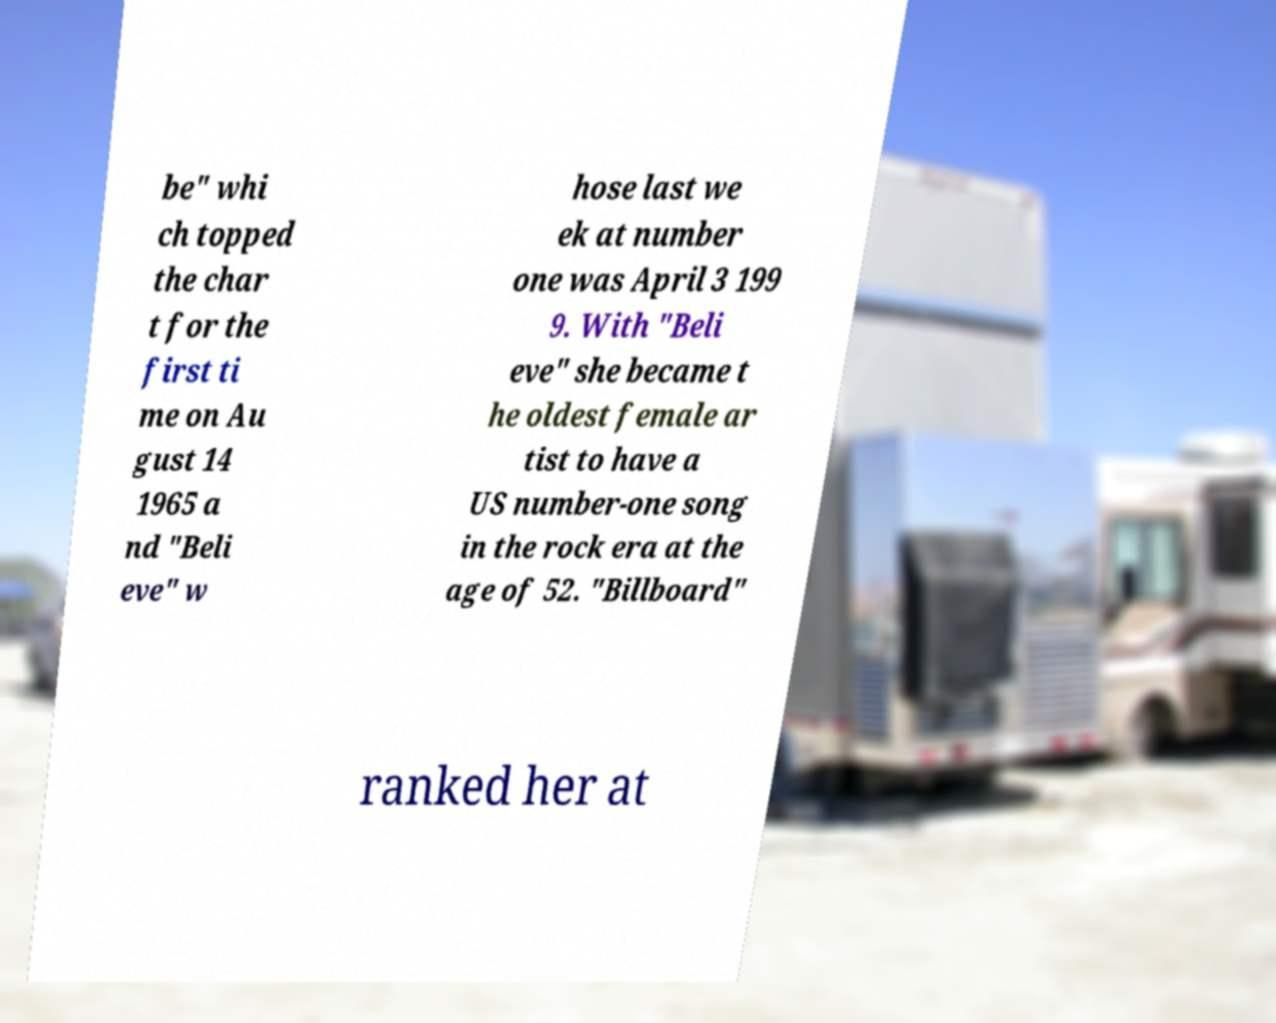I need the written content from this picture converted into text. Can you do that? be" whi ch topped the char t for the first ti me on Au gust 14 1965 a nd "Beli eve" w hose last we ek at number one was April 3 199 9. With "Beli eve" she became t he oldest female ar tist to have a US number-one song in the rock era at the age of 52. "Billboard" ranked her at 